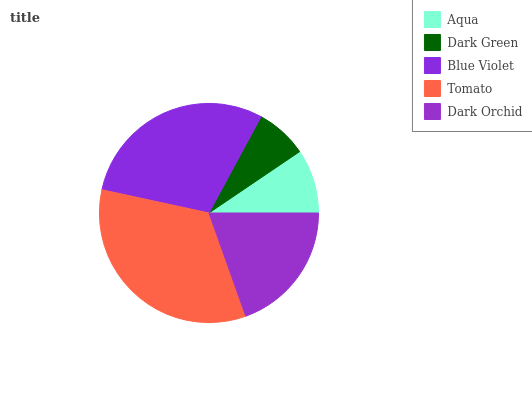Is Dark Green the minimum?
Answer yes or no. Yes. Is Tomato the maximum?
Answer yes or no. Yes. Is Blue Violet the minimum?
Answer yes or no. No. Is Blue Violet the maximum?
Answer yes or no. No. Is Blue Violet greater than Dark Green?
Answer yes or no. Yes. Is Dark Green less than Blue Violet?
Answer yes or no. Yes. Is Dark Green greater than Blue Violet?
Answer yes or no. No. Is Blue Violet less than Dark Green?
Answer yes or no. No. Is Dark Orchid the high median?
Answer yes or no. Yes. Is Dark Orchid the low median?
Answer yes or no. Yes. Is Dark Green the high median?
Answer yes or no. No. Is Aqua the low median?
Answer yes or no. No. 